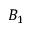Convert formula to latex. <formula><loc_0><loc_0><loc_500><loc_500>B _ { 1 }</formula> 